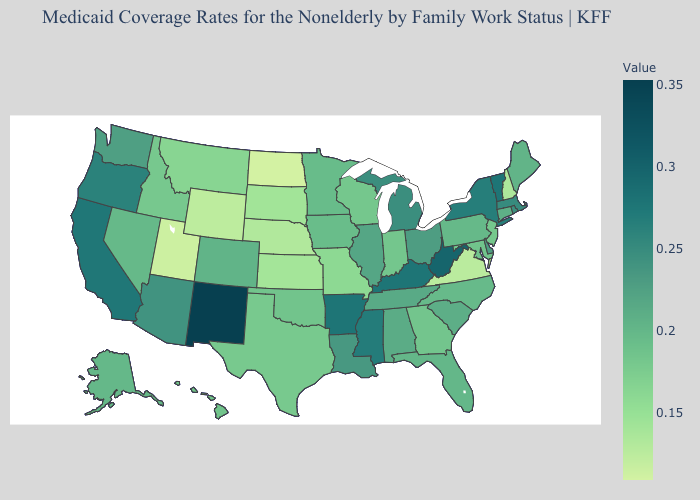Does New York have the highest value in the Northeast?
Be succinct. No. Does New York have a higher value than New Mexico?
Be succinct. No. Does the map have missing data?
Be succinct. No. Among the states that border Arkansas , which have the lowest value?
Write a very short answer. Missouri. Among the states that border Minnesota , does North Dakota have the highest value?
Keep it brief. No. 